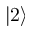Convert formula to latex. <formula><loc_0><loc_0><loc_500><loc_500>\left | 2 \right ></formula> 